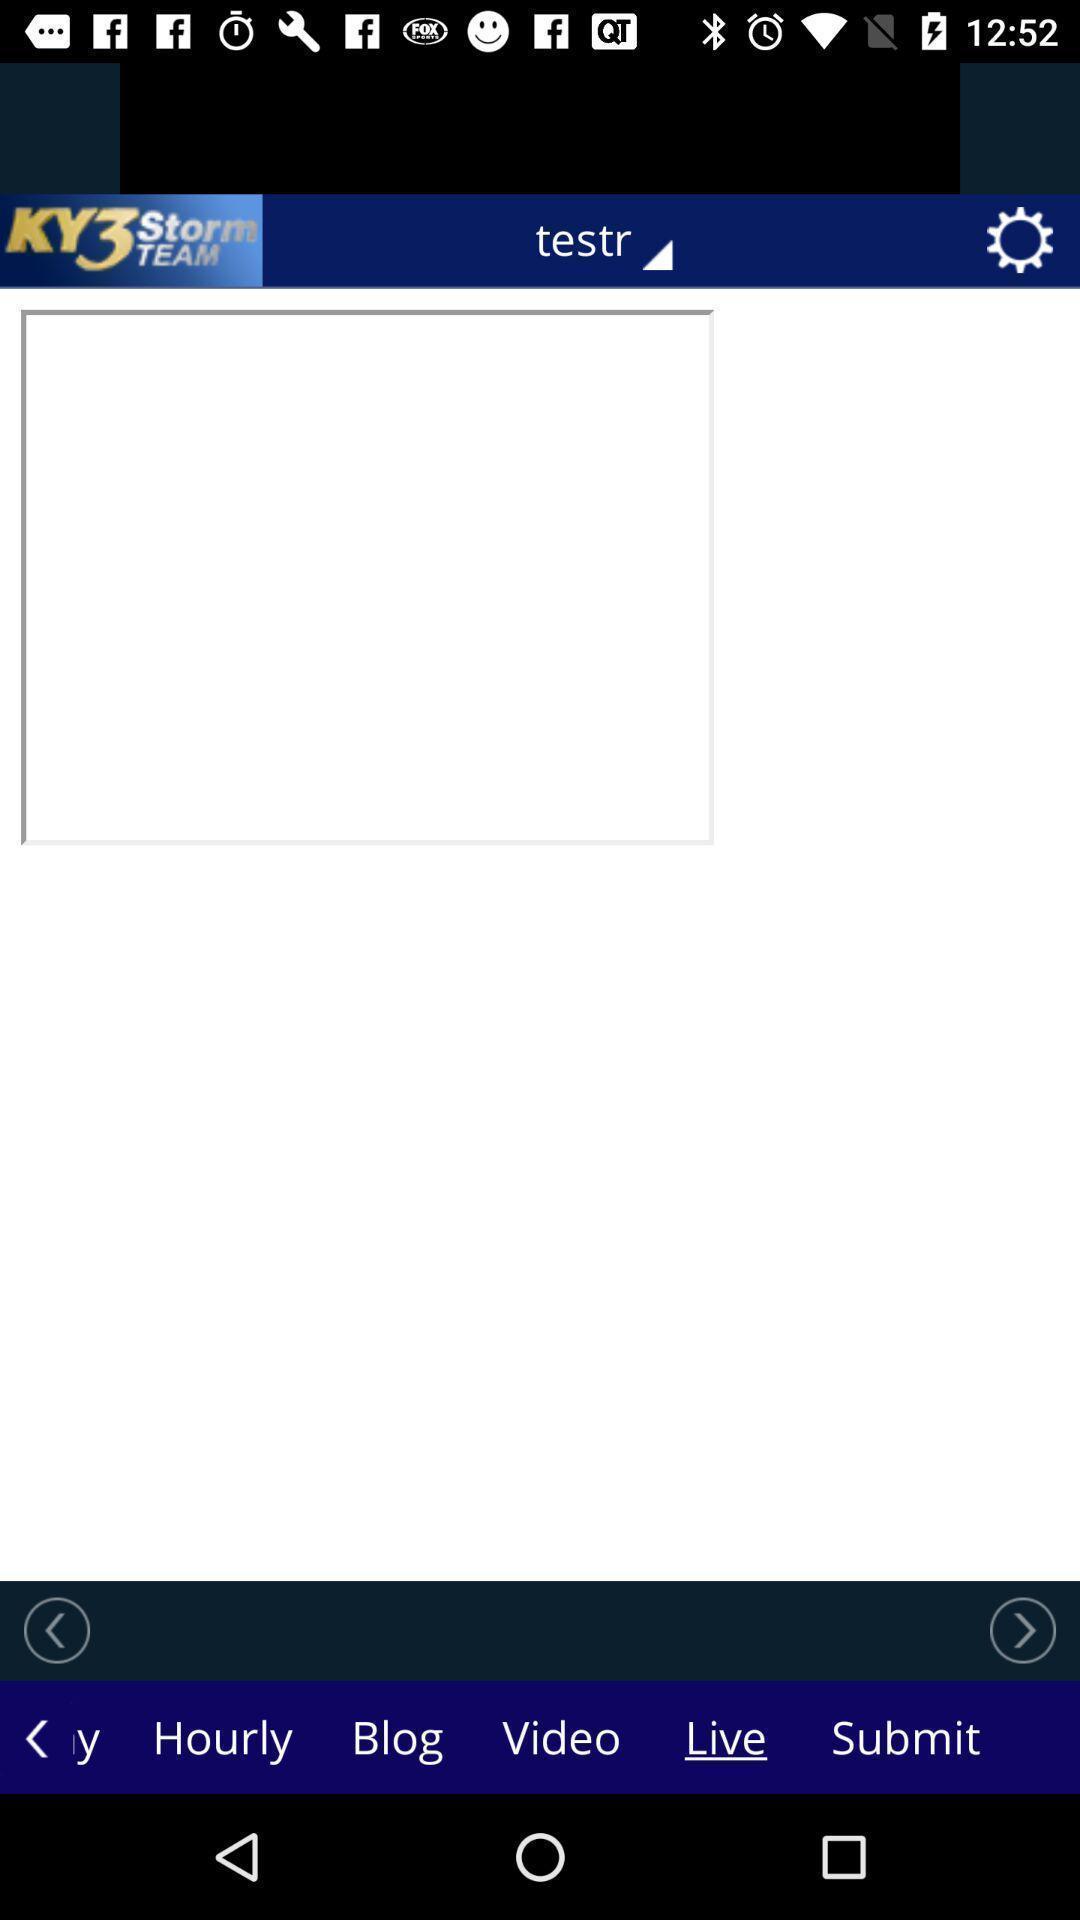Describe this image in words. Page with lot of icons is showing in weather app. 